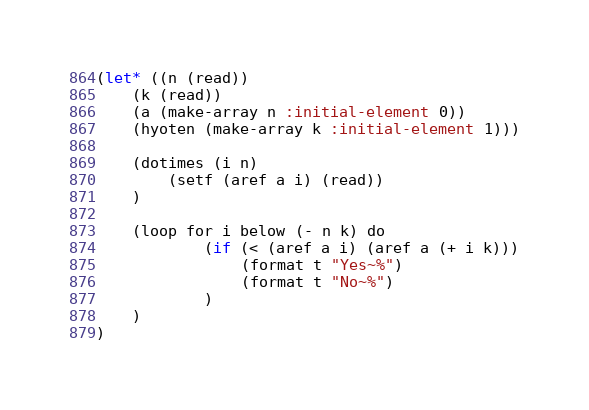<code> <loc_0><loc_0><loc_500><loc_500><_Lisp_>(let* ((n (read))
    (k (read))
    (a (make-array n :initial-element 0))
    (hyoten (make-array k :initial-element 1)))

    (dotimes (i n)
        (setf (aref a i) (read))
    )

    (loop for i below (- n k) do
            (if (< (aref a i) (aref a (+ i k)))
                (format t "Yes~%")
                (format t "No~%")
            )
    )
)</code> 